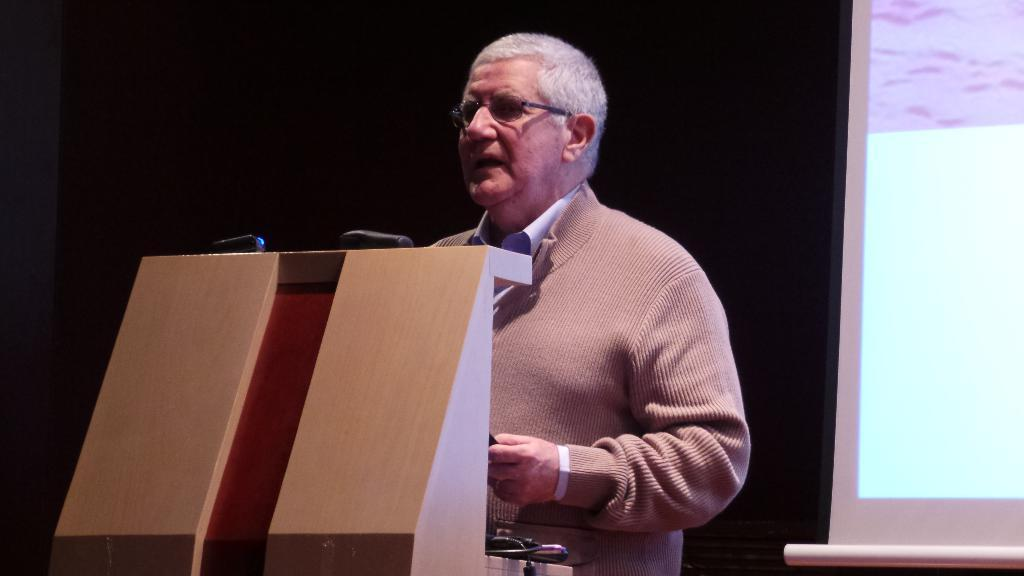Who is the main subject in the image? There is a man in the image. What is the man wearing in the image? The man is wearing spectacles in the image. What is the man doing in the image? The man is standing at a podium in the image. What can be seen in the background of the image? There is a screen in the background of the image. Is the man skiing down a slope in the image? No, the man is not skiing down a slope in the image. He is standing at a podium, and there is no indication of a slope or skiing activity in the image. 